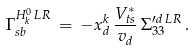<formula> <loc_0><loc_0><loc_500><loc_500>\Gamma _ { s b } ^ { H _ { k } ^ { 0 } \, L R } \, = \, - x _ { d } ^ { k } \, \frac { { V _ { t s } ^ { * } } } { v _ { d } } \, \Sigma _ { 3 3 } ^ { \prime d \, L R } \, .</formula> 